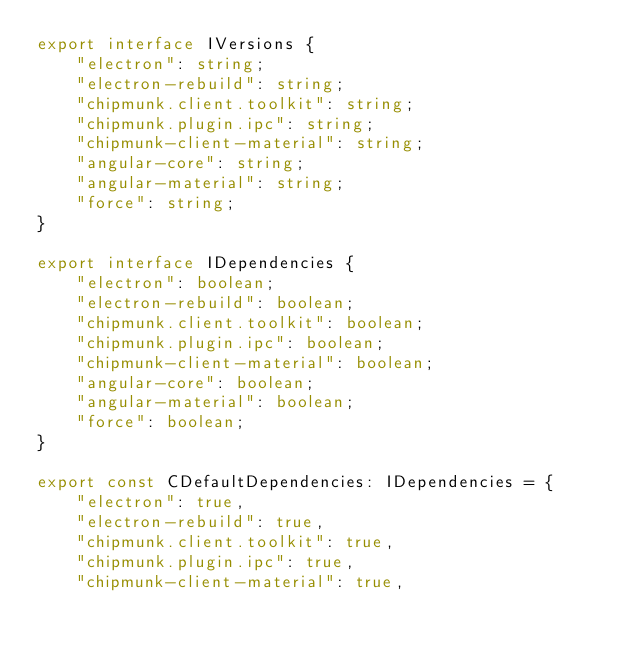<code> <loc_0><loc_0><loc_500><loc_500><_TypeScript_>export interface IVersions {
    "electron": string;
    "electron-rebuild": string;
    "chipmunk.client.toolkit": string;
    "chipmunk.plugin.ipc": string;
    "chipmunk-client-material": string;
    "angular-core": string;
    "angular-material": string;
    "force": string;
}

export interface IDependencies {
    "electron": boolean;
    "electron-rebuild": boolean;
    "chipmunk.client.toolkit": boolean;
    "chipmunk.plugin.ipc": boolean;
    "chipmunk-client-material": boolean;
    "angular-core": boolean;
    "angular-material": boolean;
    "force": boolean;
}

export const CDefaultDependencies: IDependencies = {
    "electron": true,
    "electron-rebuild": true,
    "chipmunk.client.toolkit": true,
    "chipmunk.plugin.ipc": true,
    "chipmunk-client-material": true,</code> 